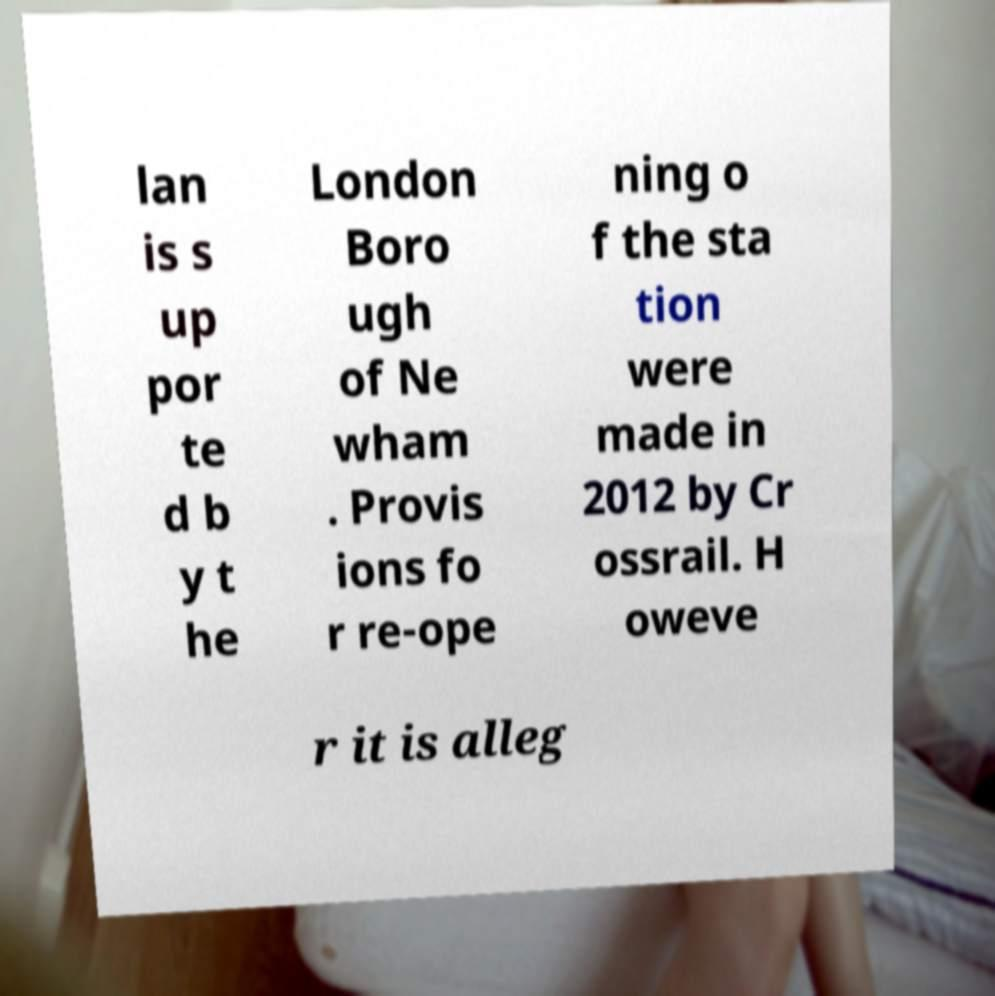For documentation purposes, I need the text within this image transcribed. Could you provide that? lan is s up por te d b y t he London Boro ugh of Ne wham . Provis ions fo r re-ope ning o f the sta tion were made in 2012 by Cr ossrail. H oweve r it is alleg 